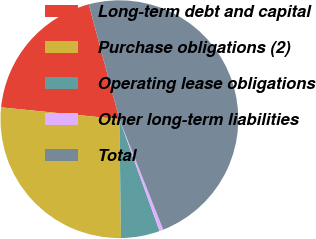Convert chart to OTSL. <chart><loc_0><loc_0><loc_500><loc_500><pie_chart><fcel>Long-term debt and capital<fcel>Purchase obligations (2)<fcel>Operating lease obligations<fcel>Other long-term liabilities<fcel>Total<nl><fcel>19.27%<fcel>26.8%<fcel>5.28%<fcel>0.52%<fcel>48.13%<nl></chart> 